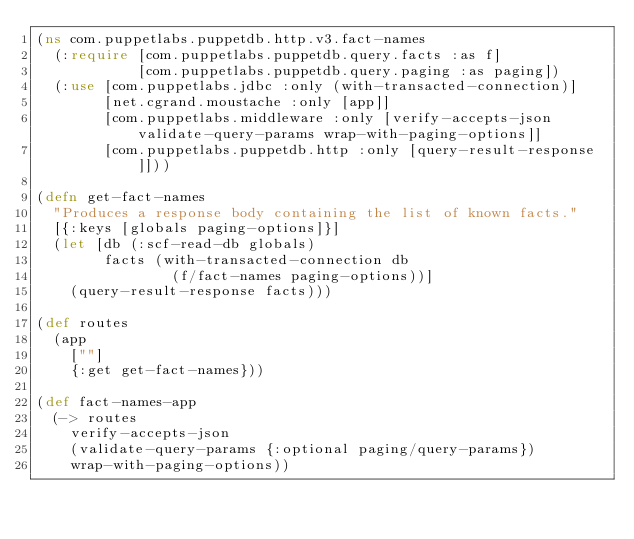<code> <loc_0><loc_0><loc_500><loc_500><_Clojure_>(ns com.puppetlabs.puppetdb.http.v3.fact-names
  (:require [com.puppetlabs.puppetdb.query.facts :as f]
            [com.puppetlabs.puppetdb.query.paging :as paging])
  (:use [com.puppetlabs.jdbc :only (with-transacted-connection)]
        [net.cgrand.moustache :only [app]]
        [com.puppetlabs.middleware :only [verify-accepts-json validate-query-params wrap-with-paging-options]]
        [com.puppetlabs.puppetdb.http :only [query-result-response]]))

(defn get-fact-names
  "Produces a response body containing the list of known facts."
  [{:keys [globals paging-options]}]
  (let [db (:scf-read-db globals)
        facts (with-transacted-connection db
                (f/fact-names paging-options))]
    (query-result-response facts)))

(def routes
  (app
    [""]
    {:get get-fact-names}))

(def fact-names-app
  (-> routes
    verify-accepts-json
    (validate-query-params {:optional paging/query-params})
    wrap-with-paging-options))
</code> 